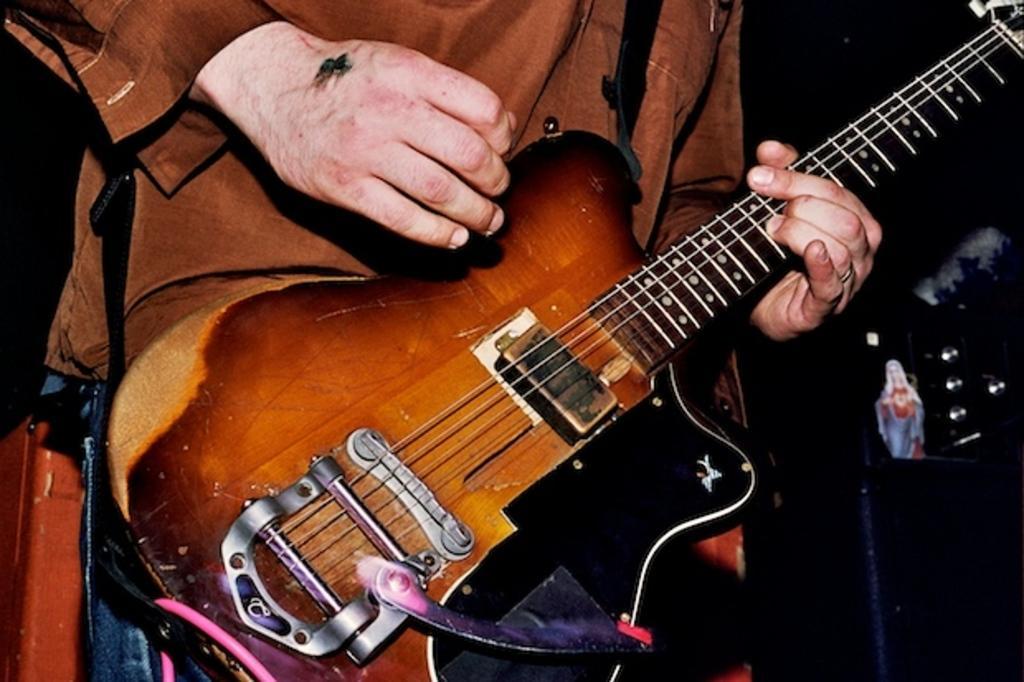Can you describe this image briefly? In this picture there is a man who is standing and playing a guitar. There is an idol on the guitar. 